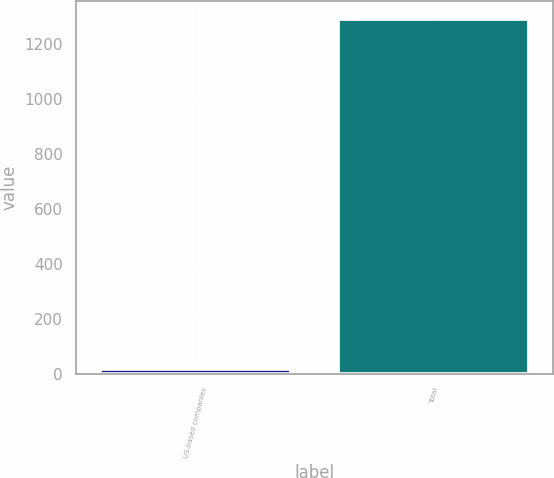Convert chart. <chart><loc_0><loc_0><loc_500><loc_500><bar_chart><fcel>US-based companies<fcel>Total<nl><fcel>15<fcel>1292<nl></chart> 